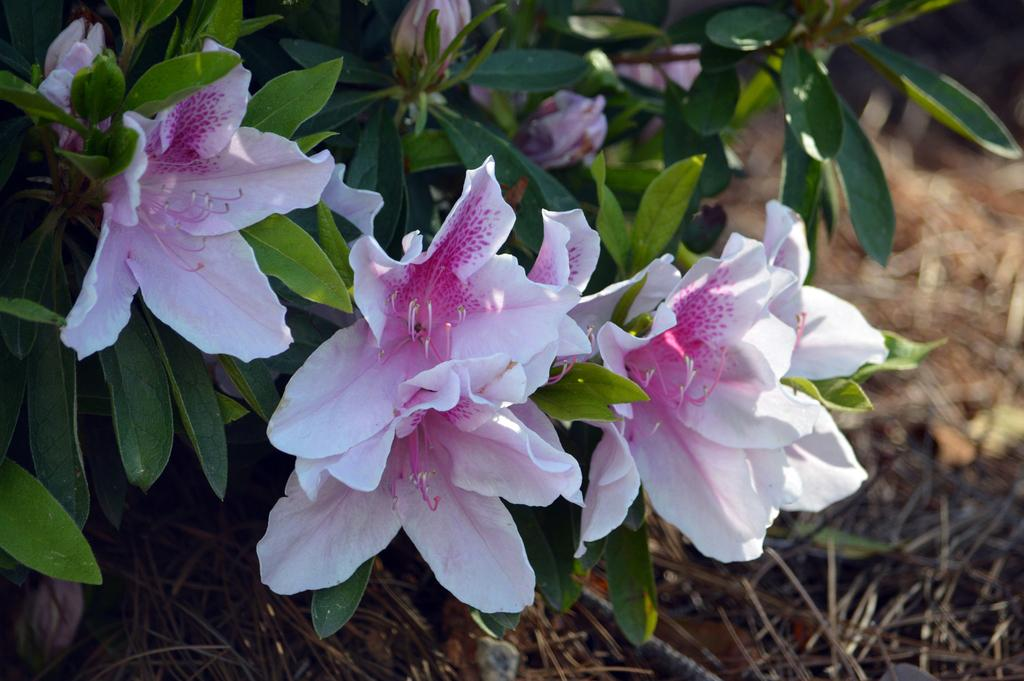What type of plant is visible in the image? There are flowers on a plant in the image. Can you describe the flowers on the plant? Unfortunately, the specific type of flowers cannot be determined from the image alone. What is the plant's primary purpose in the image? The plant's primary purpose in the image is to display the flowers. How many people are attracted to the river in the image? There is no river or people present in the image; it only features a plant with flowers. 